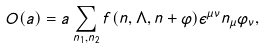<formula> <loc_0><loc_0><loc_500><loc_500>O ( a ) = a \sum _ { n _ { 1 } , n _ { 2 } } f ( n , \Lambda , n + \varphi ) \epsilon ^ { \mu \nu } n _ { \mu } \varphi _ { \nu } ,</formula> 